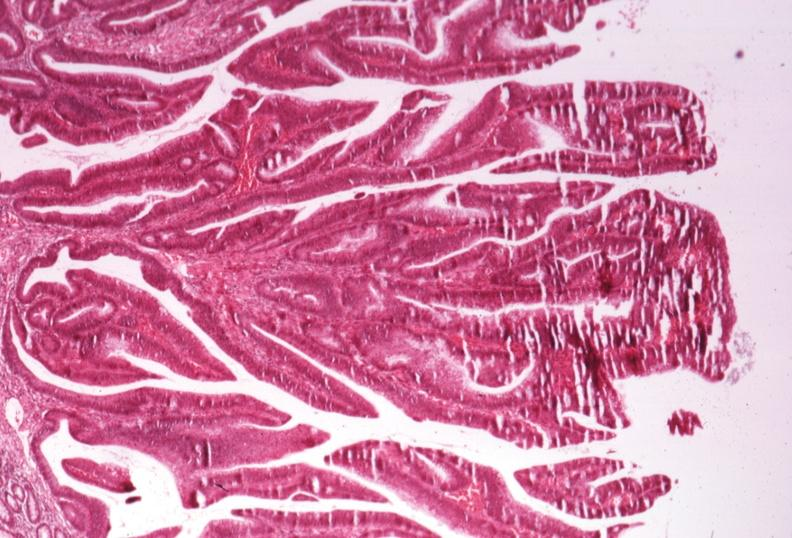s villous adenoma present?
Answer the question using a single word or phrase. Yes 